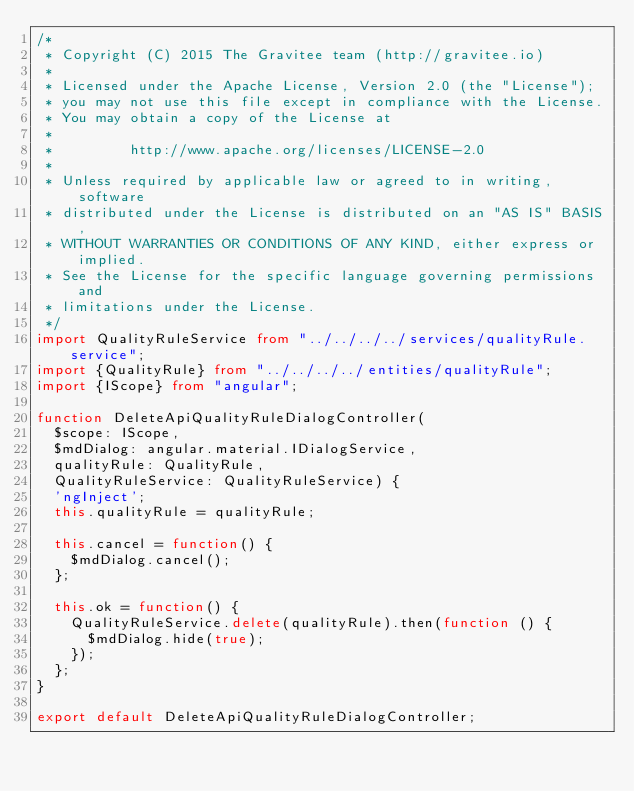Convert code to text. <code><loc_0><loc_0><loc_500><loc_500><_TypeScript_>/*
 * Copyright (C) 2015 The Gravitee team (http://gravitee.io)
 *
 * Licensed under the Apache License, Version 2.0 (the "License");
 * you may not use this file except in compliance with the License.
 * You may obtain a copy of the License at
 *
 *         http://www.apache.org/licenses/LICENSE-2.0
 *
 * Unless required by applicable law or agreed to in writing, software
 * distributed under the License is distributed on an "AS IS" BASIS,
 * WITHOUT WARRANTIES OR CONDITIONS OF ANY KIND, either express or implied.
 * See the License for the specific language governing permissions and
 * limitations under the License.
 */
import QualityRuleService from "../../../../services/qualityRule.service";
import {QualityRule} from "../../../../entities/qualityRule";
import {IScope} from "angular";

function DeleteApiQualityRuleDialogController(
  $scope: IScope,
  $mdDialog: angular.material.IDialogService,
  qualityRule: QualityRule,
  QualityRuleService: QualityRuleService) {
  'ngInject';
  this.qualityRule = qualityRule;

  this.cancel = function() {
    $mdDialog.cancel();
  };

  this.ok = function() {
    QualityRuleService.delete(qualityRule).then(function () {
      $mdDialog.hide(true);
    });
  };
}

export default DeleteApiQualityRuleDialogController;
</code> 